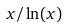<formula> <loc_0><loc_0><loc_500><loc_500>x / \ln ( x )</formula> 